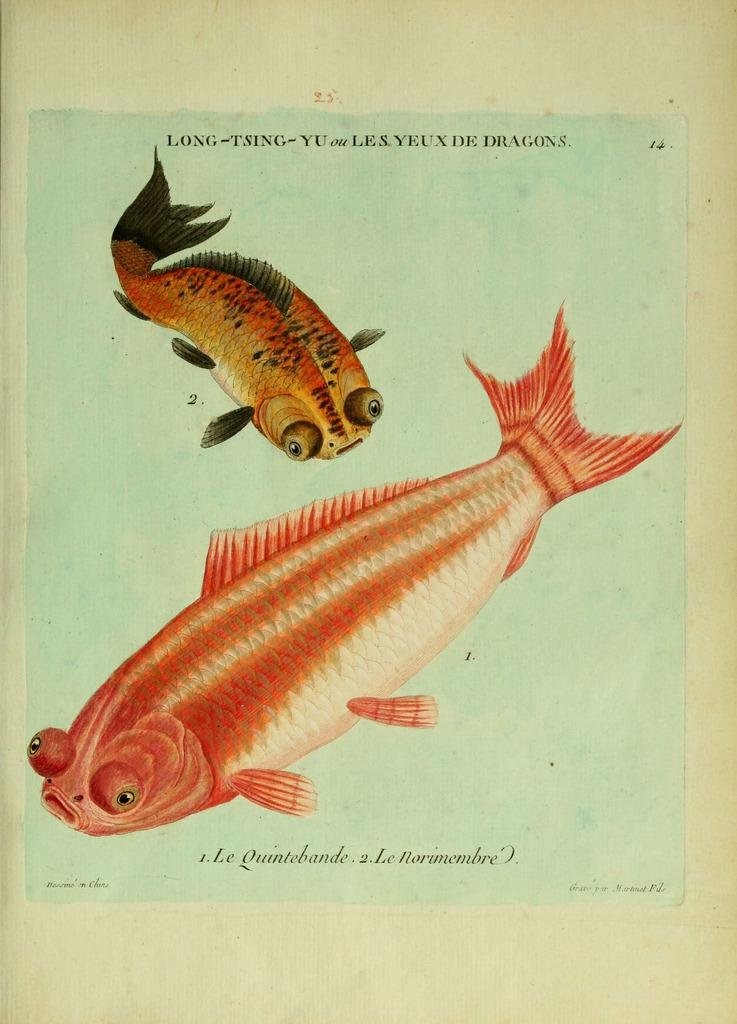What is depicted on the paper in the image? There are pictures of fishes on a paper. What else can be seen on the paper besides the pictures of fishes? There is text at the top of the paper and text at the bottom of the paper. What type of card is being used to hold the celery in the image? There is no card or celery present in the image; it only features a paper with pictures of fishes and text. 